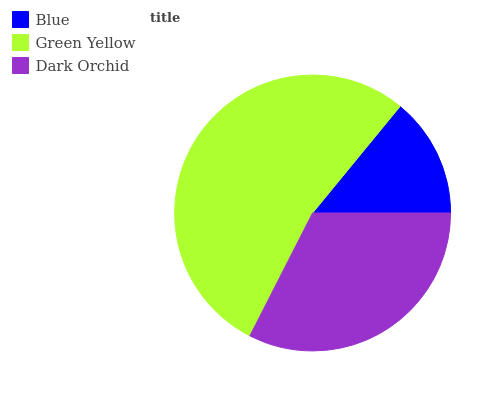Is Blue the minimum?
Answer yes or no. Yes. Is Green Yellow the maximum?
Answer yes or no. Yes. Is Dark Orchid the minimum?
Answer yes or no. No. Is Dark Orchid the maximum?
Answer yes or no. No. Is Green Yellow greater than Dark Orchid?
Answer yes or no. Yes. Is Dark Orchid less than Green Yellow?
Answer yes or no. Yes. Is Dark Orchid greater than Green Yellow?
Answer yes or no. No. Is Green Yellow less than Dark Orchid?
Answer yes or no. No. Is Dark Orchid the high median?
Answer yes or no. Yes. Is Dark Orchid the low median?
Answer yes or no. Yes. Is Blue the high median?
Answer yes or no. No. Is Blue the low median?
Answer yes or no. No. 